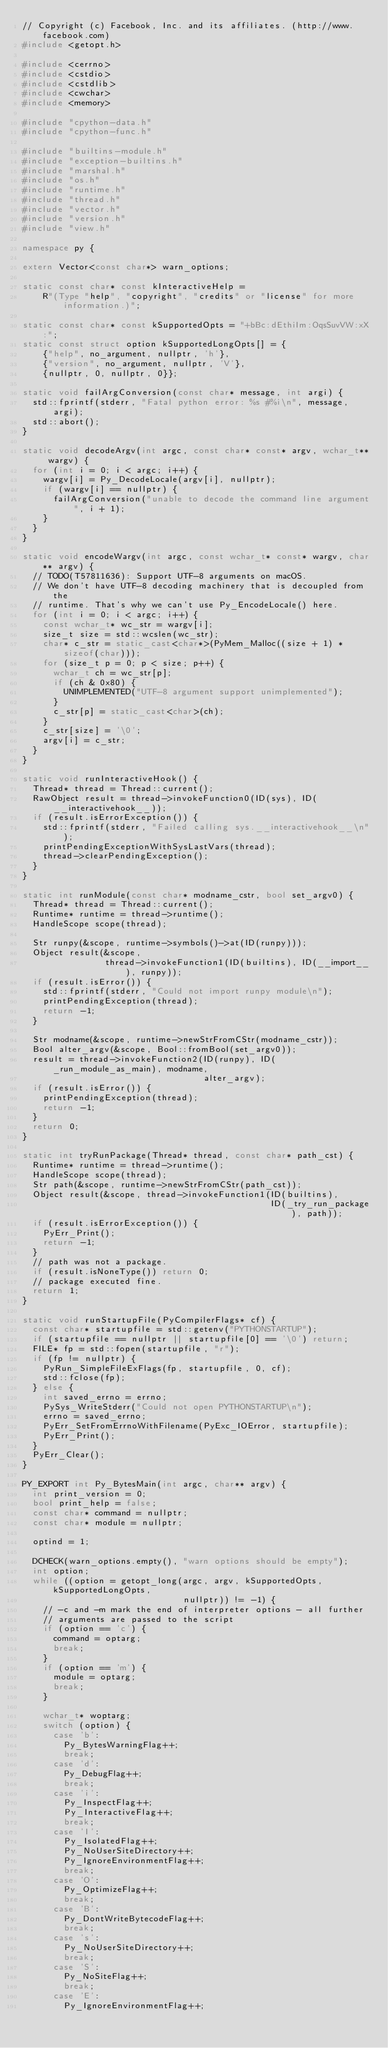<code> <loc_0><loc_0><loc_500><loc_500><_C++_>// Copyright (c) Facebook, Inc. and its affiliates. (http://www.facebook.com)
#include <getopt.h>

#include <cerrno>
#include <cstdio>
#include <cstdlib>
#include <cwchar>
#include <memory>

#include "cpython-data.h"
#include "cpython-func.h"

#include "builtins-module.h"
#include "exception-builtins.h"
#include "marshal.h"
#include "os.h"
#include "runtime.h"
#include "thread.h"
#include "vector.h"
#include "version.h"
#include "view.h"

namespace py {

extern Vector<const char*> warn_options;

static const char* const kInteractiveHelp =
    R"(Type "help", "copyright", "credits" or "license" for more information.)";

static const char* const kSupportedOpts = "+bBc:dEthiIm:OqsSuvVW:xX:";
static const struct option kSupportedLongOpts[] = {
    {"help", no_argument, nullptr, 'h'},
    {"version", no_argument, nullptr, 'V'},
    {nullptr, 0, nullptr, 0}};

static void failArgConversion(const char* message, int argi) {
  std::fprintf(stderr, "Fatal python error: %s #%i\n", message, argi);
  std::abort();
}

static void decodeArgv(int argc, const char* const* argv, wchar_t** wargv) {
  for (int i = 0; i < argc; i++) {
    wargv[i] = Py_DecodeLocale(argv[i], nullptr);
    if (wargv[i] == nullptr) {
      failArgConversion("unable to decode the command line argument", i + 1);
    }
  }
}

static void encodeWargv(int argc, const wchar_t* const* wargv, char** argv) {
  // TODO(T57811636): Support UTF-8 arguments on macOS.
  // We don't have UTF-8 decoding machinery that is decoupled from the
  // runtime. That's why we can't use Py_EncodeLocale() here.
  for (int i = 0; i < argc; i++) {
    const wchar_t* wc_str = wargv[i];
    size_t size = std::wcslen(wc_str);
    char* c_str = static_cast<char*>(PyMem_Malloc((size + 1) * sizeof(char)));
    for (size_t p = 0; p < size; p++) {
      wchar_t ch = wc_str[p];
      if (ch & 0x80) {
        UNIMPLEMENTED("UTF-8 argument support unimplemented");
      }
      c_str[p] = static_cast<char>(ch);
    }
    c_str[size] = '\0';
    argv[i] = c_str;
  }
}

static void runInteractiveHook() {
  Thread* thread = Thread::current();
  RawObject result = thread->invokeFunction0(ID(sys), ID(__interactivehook__));
  if (result.isErrorException()) {
    std::fprintf(stderr, "Failed calling sys.__interactivehook__\n");
    printPendingExceptionWithSysLastVars(thread);
    thread->clearPendingException();
  }
}

static int runModule(const char* modname_cstr, bool set_argv0) {
  Thread* thread = Thread::current();
  Runtime* runtime = thread->runtime();
  HandleScope scope(thread);

  Str runpy(&scope, runtime->symbols()->at(ID(runpy)));
  Object result(&scope,
                thread->invokeFunction1(ID(builtins), ID(__import__), runpy));
  if (result.isError()) {
    std::fprintf(stderr, "Could not import runpy module\n");
    printPendingException(thread);
    return -1;
  }

  Str modname(&scope, runtime->newStrFromCStr(modname_cstr));
  Bool alter_argv(&scope, Bool::fromBool(set_argv0));
  result = thread->invokeFunction2(ID(runpy), ID(_run_module_as_main), modname,
                                   alter_argv);
  if (result.isError()) {
    printPendingException(thread);
    return -1;
  }
  return 0;
}

static int tryRunPackage(Thread* thread, const char* path_cst) {
  Runtime* runtime = thread->runtime();
  HandleScope scope(thread);
  Str path(&scope, runtime->newStrFromCStr(path_cst));
  Object result(&scope, thread->invokeFunction1(ID(builtins),
                                                ID(_try_run_package), path));
  if (result.isErrorException()) {
    PyErr_Print();
    return -1;
  }
  // path was not a package.
  if (result.isNoneType()) return 0;
  // package executed fine.
  return 1;
}

static void runStartupFile(PyCompilerFlags* cf) {
  const char* startupfile = std::getenv("PYTHONSTARTUP");
  if (startupfile == nullptr || startupfile[0] == '\0') return;
  FILE* fp = std::fopen(startupfile, "r");
  if (fp != nullptr) {
    PyRun_SimpleFileExFlags(fp, startupfile, 0, cf);
    std::fclose(fp);
  } else {
    int saved_errno = errno;
    PySys_WriteStderr("Could not open PYTHONSTARTUP\n");
    errno = saved_errno;
    PyErr_SetFromErrnoWithFilename(PyExc_IOError, startupfile);
    PyErr_Print();
  }
  PyErr_Clear();
}

PY_EXPORT int Py_BytesMain(int argc, char** argv) {
  int print_version = 0;
  bool print_help = false;
  const char* command = nullptr;
  const char* module = nullptr;

  optind = 1;

  DCHECK(warn_options.empty(), "warn options should be empty");
  int option;
  while ((option = getopt_long(argc, argv, kSupportedOpts, kSupportedLongOpts,
                               nullptr)) != -1) {
    // -c and -m mark the end of interpreter options - all further
    // arguments are passed to the script
    if (option == 'c') {
      command = optarg;
      break;
    }
    if (option == 'm') {
      module = optarg;
      break;
    }

    wchar_t* woptarg;
    switch (option) {
      case 'b':
        Py_BytesWarningFlag++;
        break;
      case 'd':
        Py_DebugFlag++;
        break;
      case 'i':
        Py_InspectFlag++;
        Py_InteractiveFlag++;
        break;
      case 'I':
        Py_IsolatedFlag++;
        Py_NoUserSiteDirectory++;
        Py_IgnoreEnvironmentFlag++;
        break;
      case 'O':
        Py_OptimizeFlag++;
        break;
      case 'B':
        Py_DontWriteBytecodeFlag++;
        break;
      case 's':
        Py_NoUserSiteDirectory++;
        break;
      case 'S':
        Py_NoSiteFlag++;
        break;
      case 'E':
        Py_IgnoreEnvironmentFlag++;</code> 